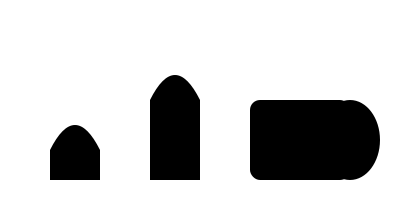Identify the personal protective equipment (PPE) represented by the silhouette labeled 'C' in the image above. To identify the PPE represented by silhouette 'C', let's analyze each shape:

1. Shape A (leftmost): This represents a face shield, with a curved top and straight bottom.
2. Shape B (second from left): This depicts a respirator or N95 mask, with its distinctive curved shape.
3. Shape C (third from left): This shows a rectangular shape with rounded corners, characteristic of safety goggles or protective eyewear.
4. Shape D (rightmost): This oval shape likely represents an ear muff or hearing protection.

The rectangular shape with rounded corners (C) is typically used to represent safety goggles or protective eyewear in PPE silhouette diagrams. These are essential for protecting the eyes from splashes, droplets, or airborne particles in healthcare settings.
Answer: Safety goggles 